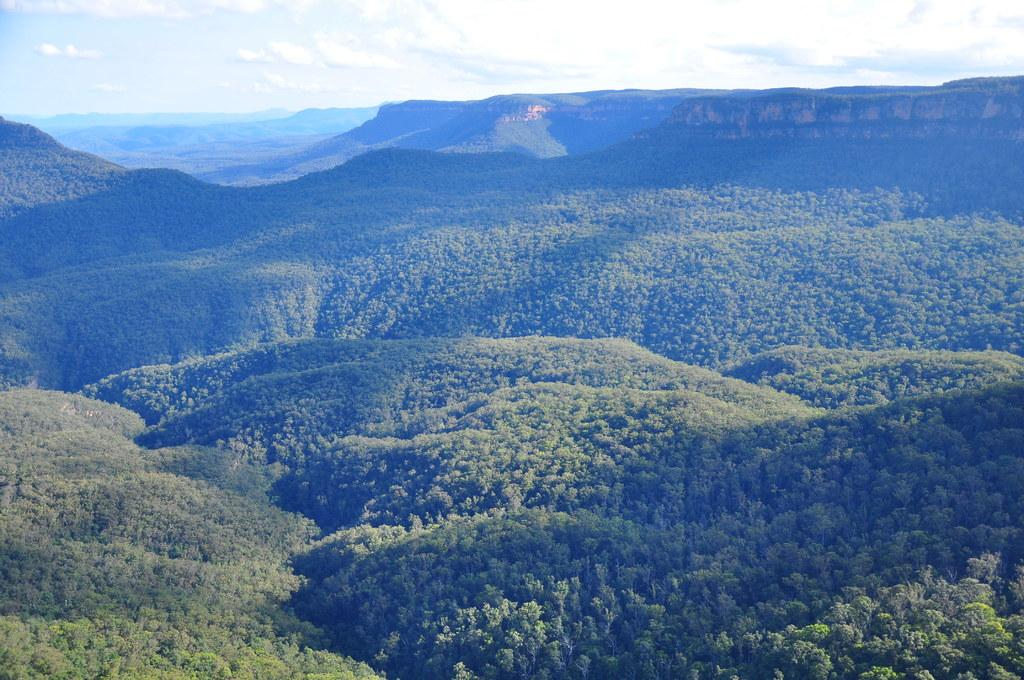What type of natural formation can be seen in the image? There are mountains in the image. What is present on the mountains? There are trees on the mountains. What is visible at the top of the image? The sky is visible at the top of the image. Where is the prison located in the image? There is no prison present in the image. Can you describe the father's attire in the image? There is no father present in the image. 